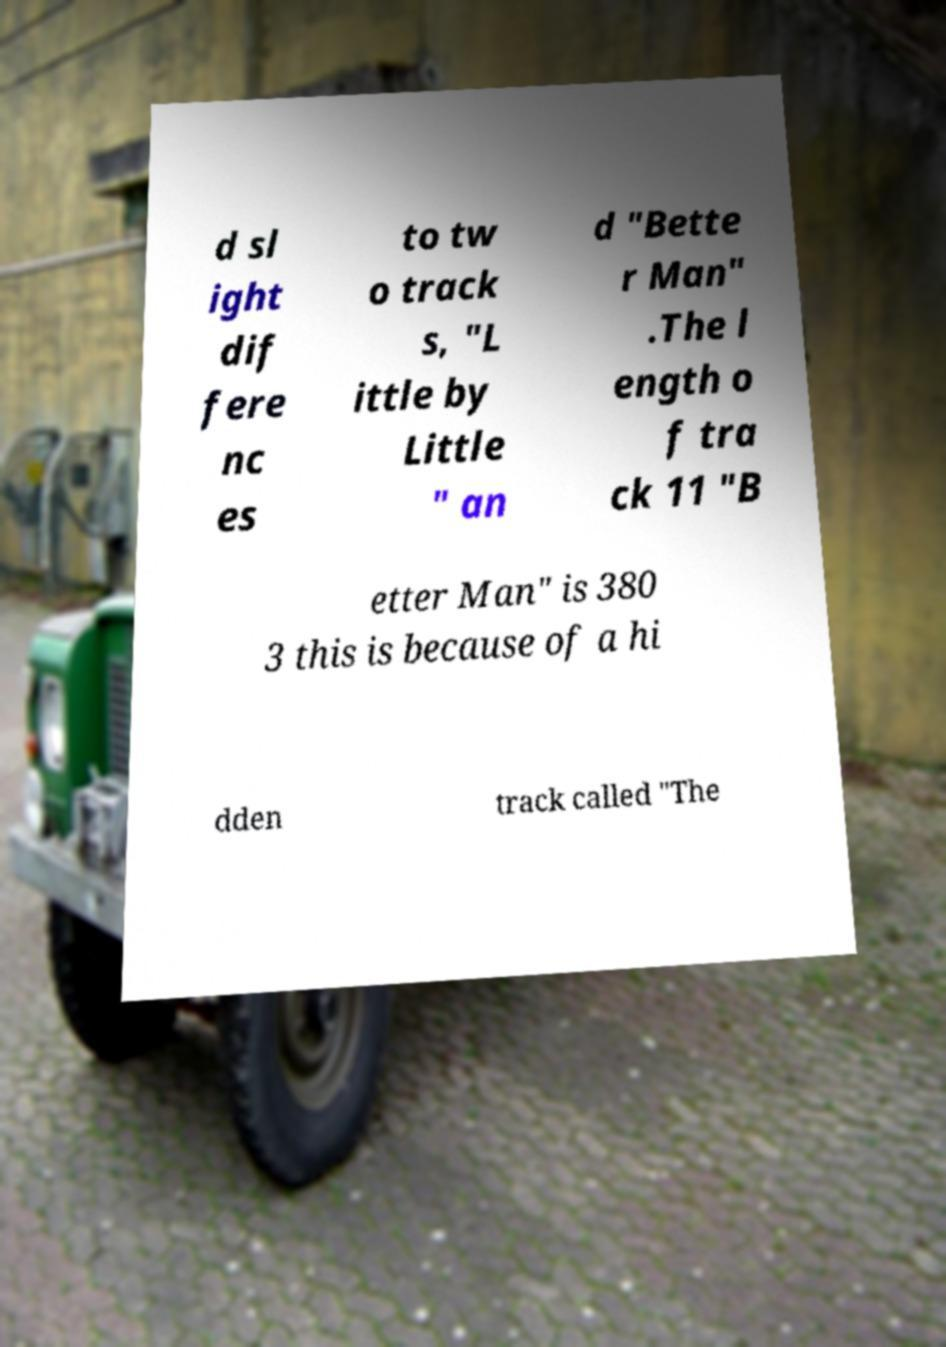For documentation purposes, I need the text within this image transcribed. Could you provide that? d sl ight dif fere nc es to tw o track s, "L ittle by Little " an d "Bette r Man" .The l ength o f tra ck 11 "B etter Man" is 380 3 this is because of a hi dden track called "The 